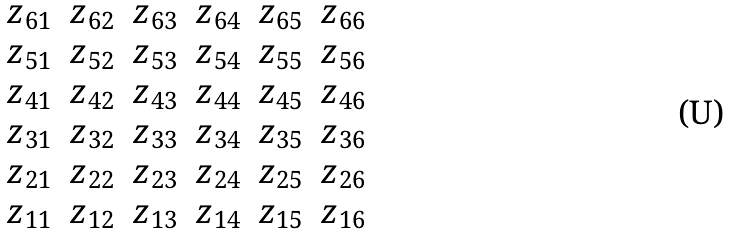Convert formula to latex. <formula><loc_0><loc_0><loc_500><loc_500>\begin{matrix} z _ { 6 1 } & z _ { 6 2 } & z _ { 6 3 } & z _ { 6 4 } & z _ { 6 5 } & z _ { 6 6 } \\ z _ { 5 1 } & z _ { 5 2 } & z _ { 5 3 } & z _ { 5 4 } & z _ { 5 5 } & z _ { 5 6 } \\ z _ { 4 1 } & z _ { 4 2 } & z _ { 4 3 } & z _ { 4 4 } & z _ { 4 5 } & z _ { 4 6 } \\ z _ { 3 1 } & z _ { 3 2 } & z _ { 3 3 } & z _ { 3 4 } & z _ { 3 5 } & z _ { 3 6 } \\ z _ { 2 1 } & z _ { 2 2 } & z _ { 2 3 } & z _ { 2 4 } & z _ { 2 5 } & z _ { 2 6 } \\ z _ { 1 1 } & z _ { 1 2 } & z _ { 1 3 } & z _ { 1 4 } & z _ { 1 5 } & z _ { 1 6 } \end{matrix}</formula> 